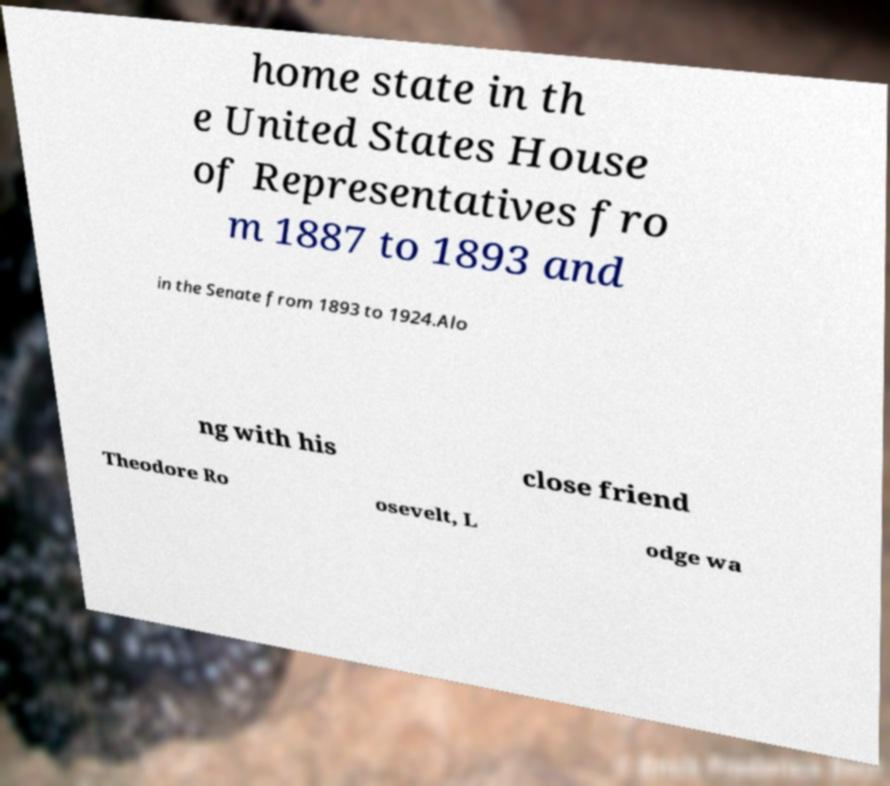Could you extract and type out the text from this image? home state in th e United States House of Representatives fro m 1887 to 1893 and in the Senate from 1893 to 1924.Alo ng with his close friend Theodore Ro osevelt, L odge wa 